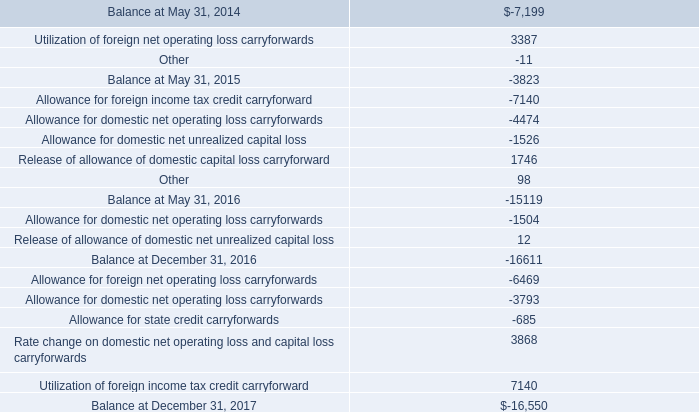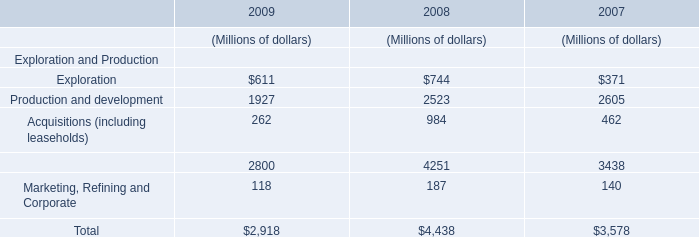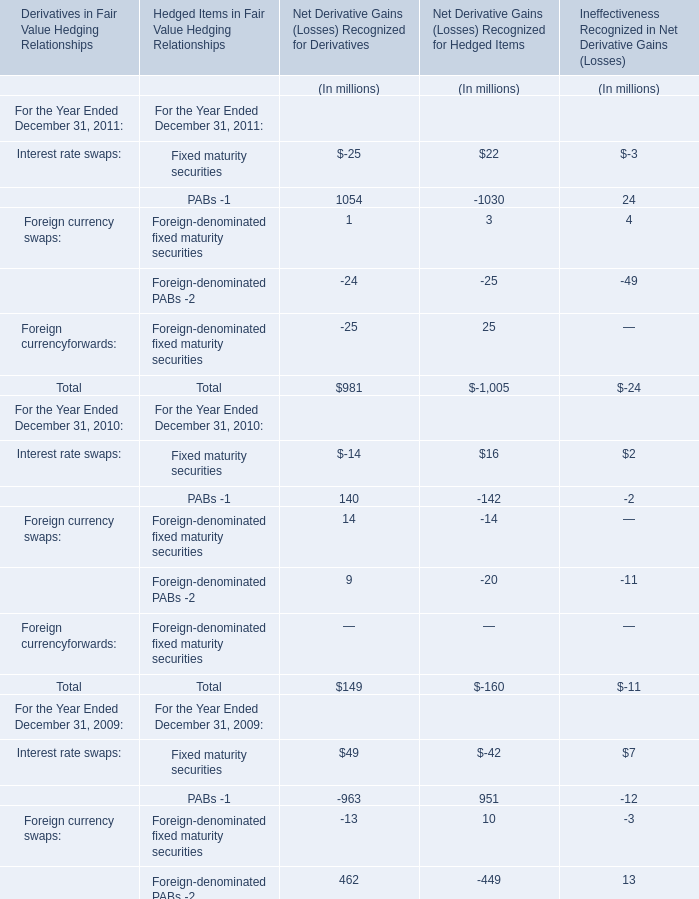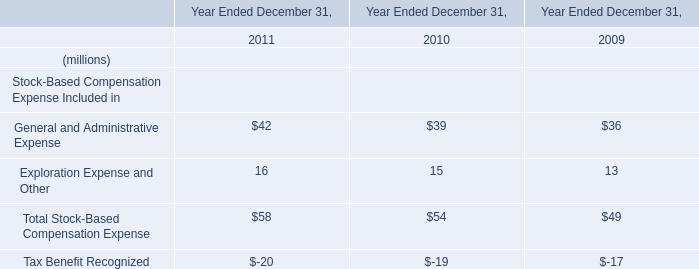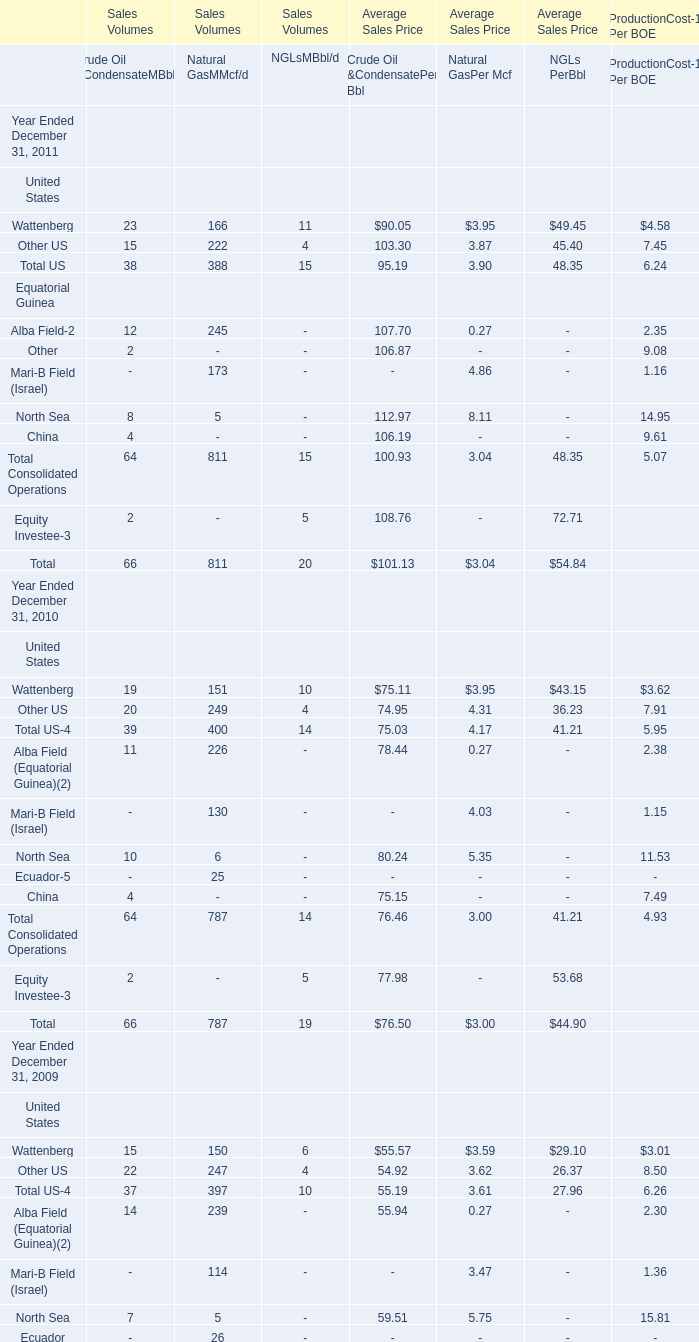What is the ratio of Fixed maturity securities of Net Derivative Gains (Losses) Recognized for Derivatives in Table 2 to the Marketing, Refining and Corporate in Table 1 in 2009? 
Computations: (49 / 118)
Answer: 0.41525. 